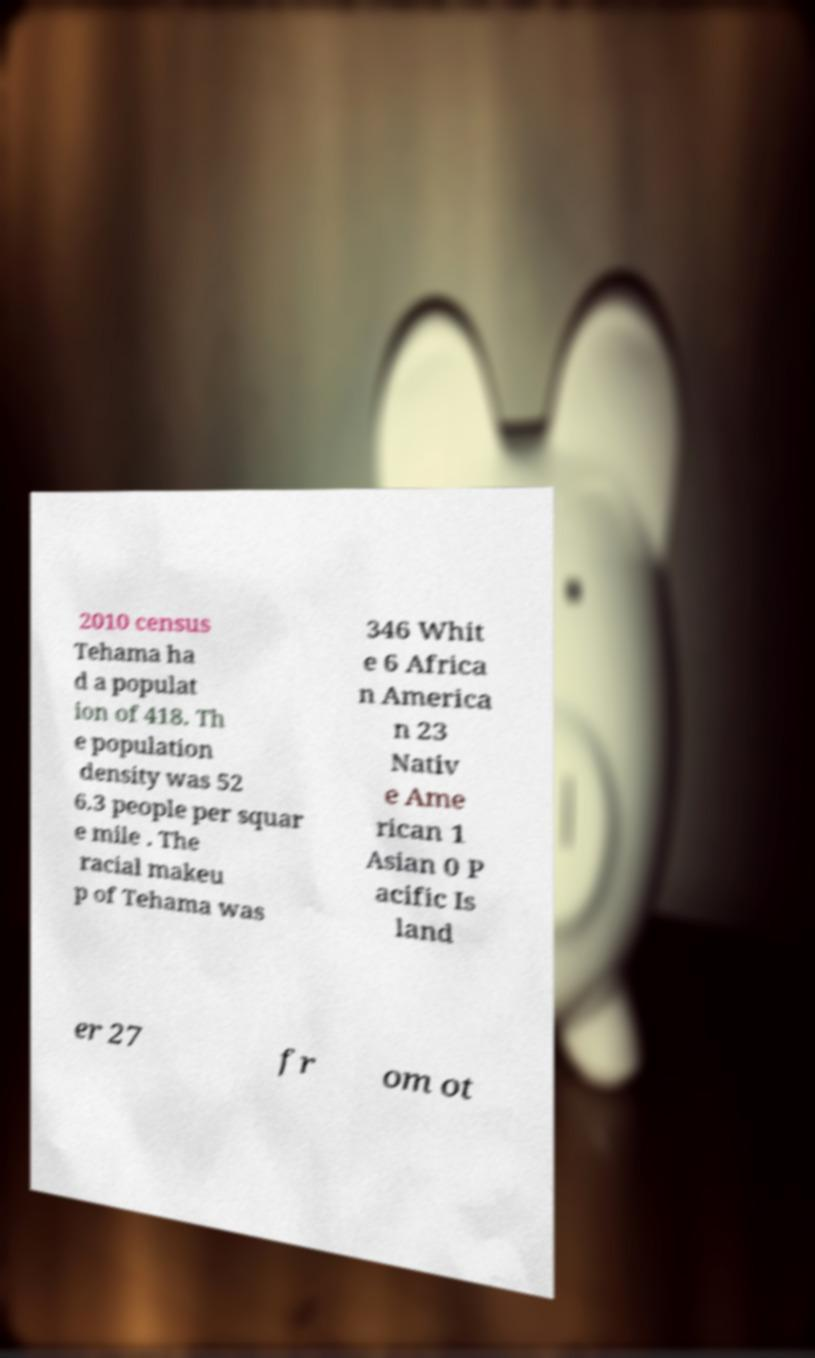For documentation purposes, I need the text within this image transcribed. Could you provide that? 2010 census Tehama ha d a populat ion of 418. Th e population density was 52 6.3 people per squar e mile . The racial makeu p of Tehama was 346 Whit e 6 Africa n America n 23 Nativ e Ame rican 1 Asian 0 P acific Is land er 27 fr om ot 